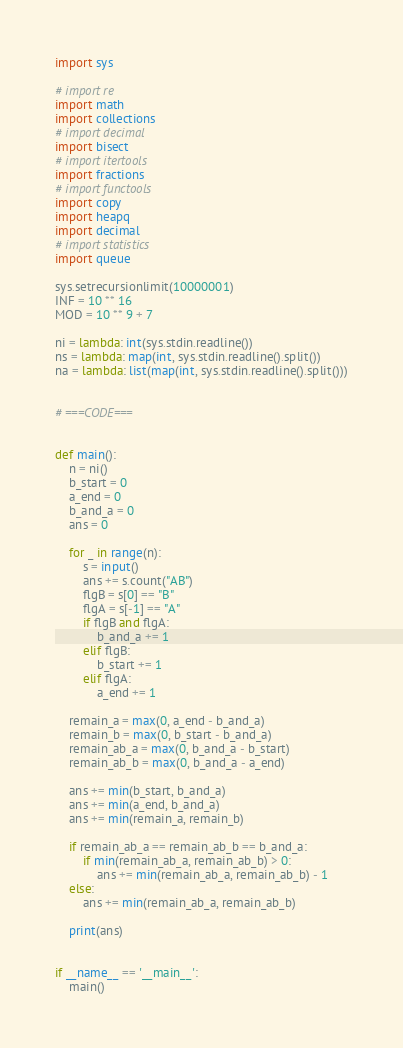Convert code to text. <code><loc_0><loc_0><loc_500><loc_500><_Python_>import sys

# import re
import math
import collections
# import decimal
import bisect
# import itertools
import fractions
# import functools
import copy
import heapq
import decimal
# import statistics
import queue

sys.setrecursionlimit(10000001)
INF = 10 ** 16
MOD = 10 ** 9 + 7

ni = lambda: int(sys.stdin.readline())
ns = lambda: map(int, sys.stdin.readline().split())
na = lambda: list(map(int, sys.stdin.readline().split()))


# ===CODE===


def main():
    n = ni()
    b_start = 0
    a_end = 0
    b_and_a = 0
    ans = 0

    for _ in range(n):
        s = input()
        ans += s.count("AB")
        flgB = s[0] == "B"
        flgA = s[-1] == "A"
        if flgB and flgA:
            b_and_a += 1
        elif flgB:
            b_start += 1
        elif flgA:
            a_end += 1

    remain_a = max(0, a_end - b_and_a)
    remain_b = max(0, b_start - b_and_a)
    remain_ab_a = max(0, b_and_a - b_start)
    remain_ab_b = max(0, b_and_a - a_end)

    ans += min(b_start, b_and_a)
    ans += min(a_end, b_and_a)
    ans += min(remain_a, remain_b)

    if remain_ab_a == remain_ab_b == b_and_a:
        if min(remain_ab_a, remain_ab_b) > 0:
            ans += min(remain_ab_a, remain_ab_b) - 1
    else:
        ans += min(remain_ab_a, remain_ab_b)

    print(ans)


if __name__ == '__main__':
    main()
</code> 